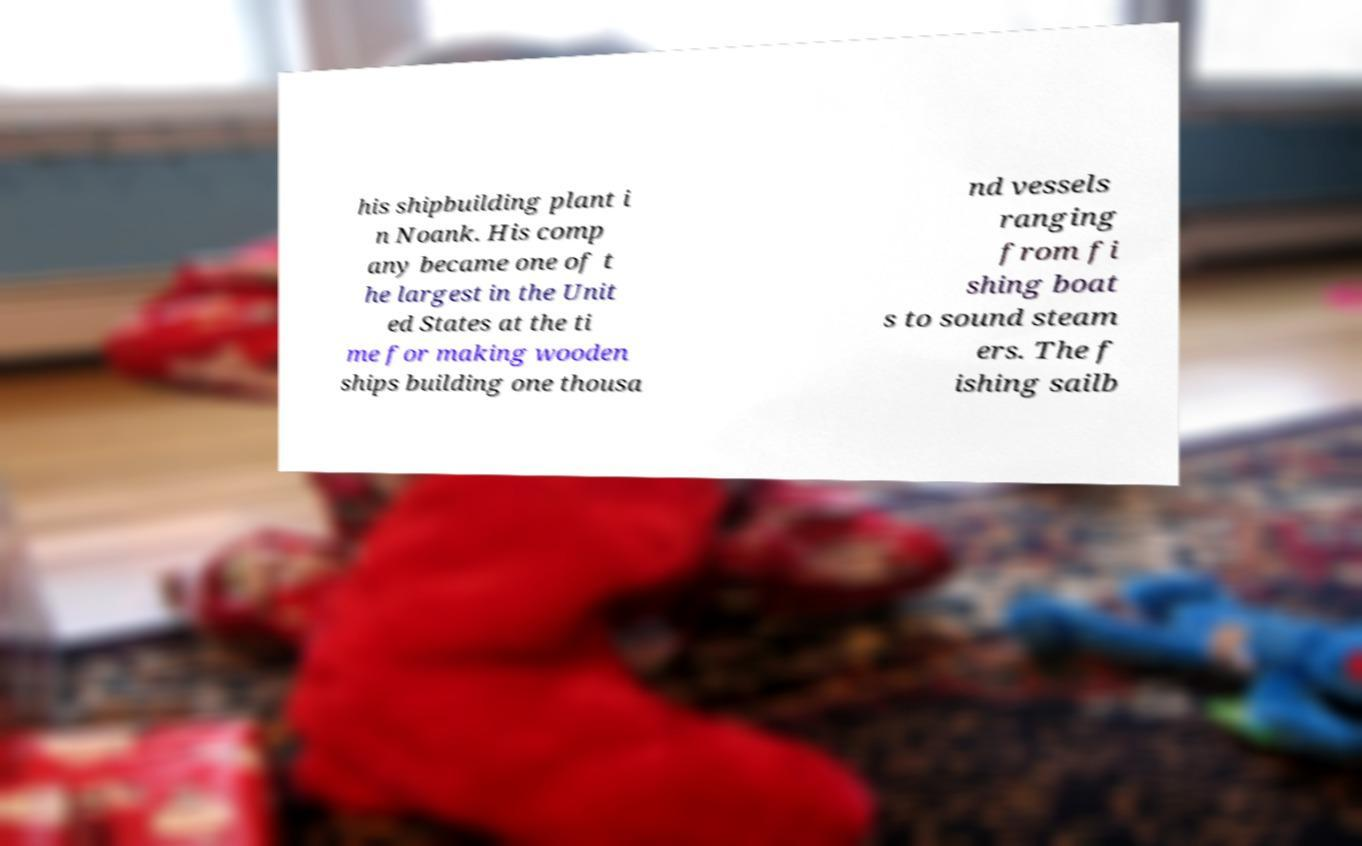For documentation purposes, I need the text within this image transcribed. Could you provide that? his shipbuilding plant i n Noank. His comp any became one of t he largest in the Unit ed States at the ti me for making wooden ships building one thousa nd vessels ranging from fi shing boat s to sound steam ers. The f ishing sailb 